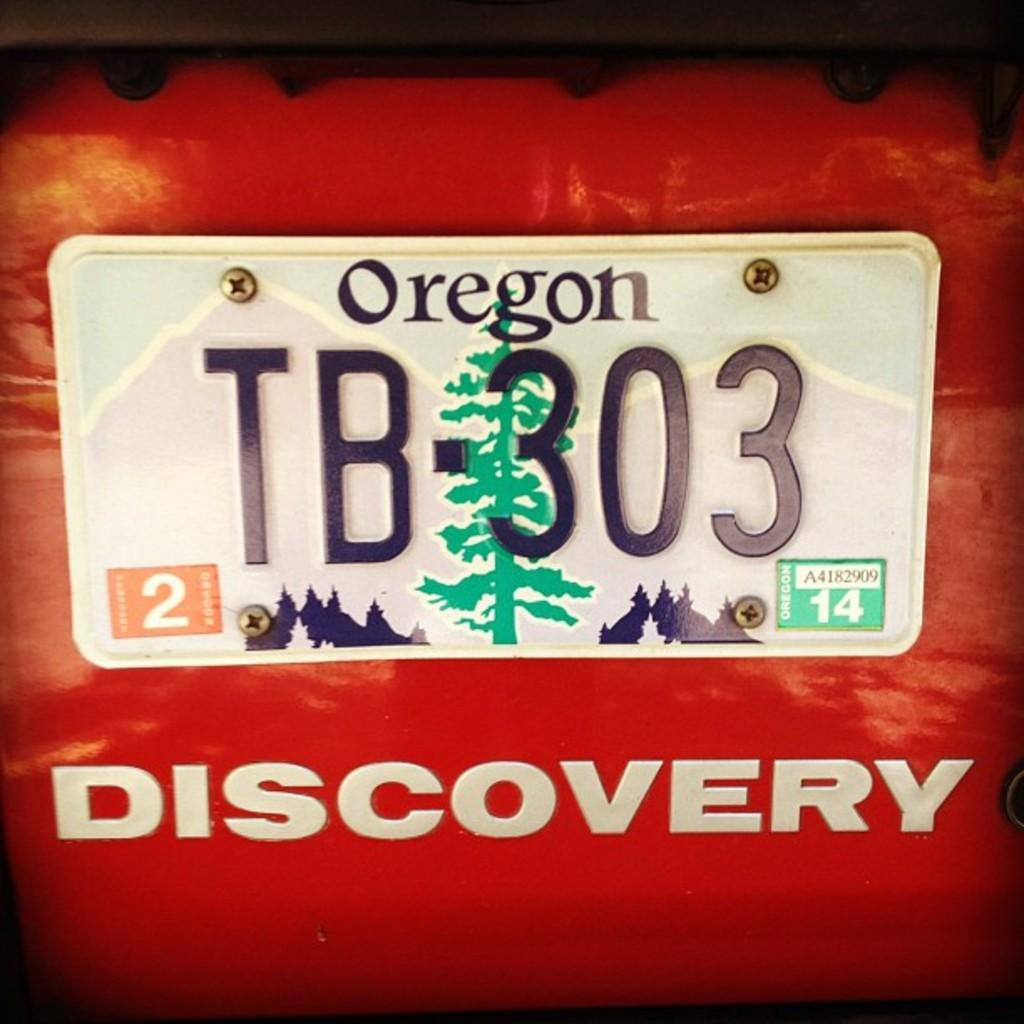<image>
Relay a brief, clear account of the picture shown. An Oregon liscense plate on an orange discovery vehicle. 